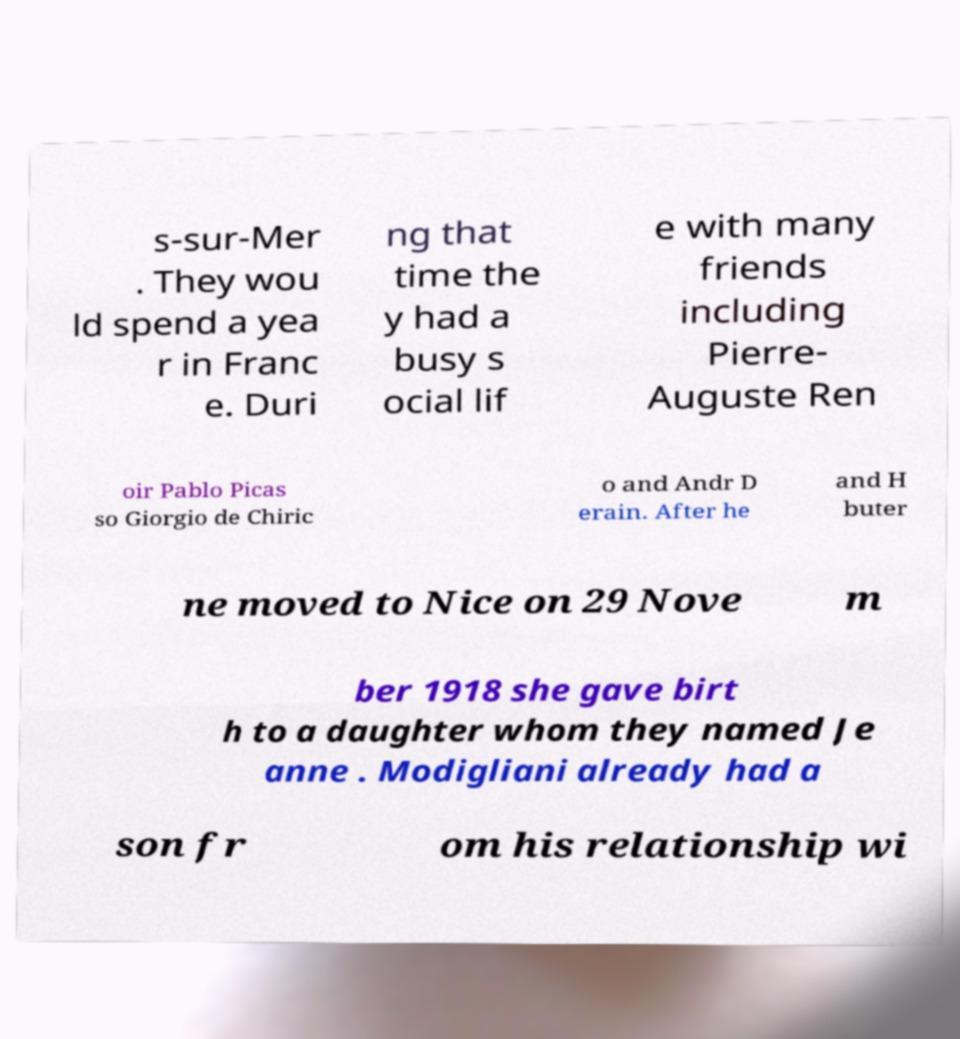Could you extract and type out the text from this image? s-sur-Mer . They wou ld spend a yea r in Franc e. Duri ng that time the y had a busy s ocial lif e with many friends including Pierre- Auguste Ren oir Pablo Picas so Giorgio de Chiric o and Andr D erain. After he and H buter ne moved to Nice on 29 Nove m ber 1918 she gave birt h to a daughter whom they named Je anne . Modigliani already had a son fr om his relationship wi 